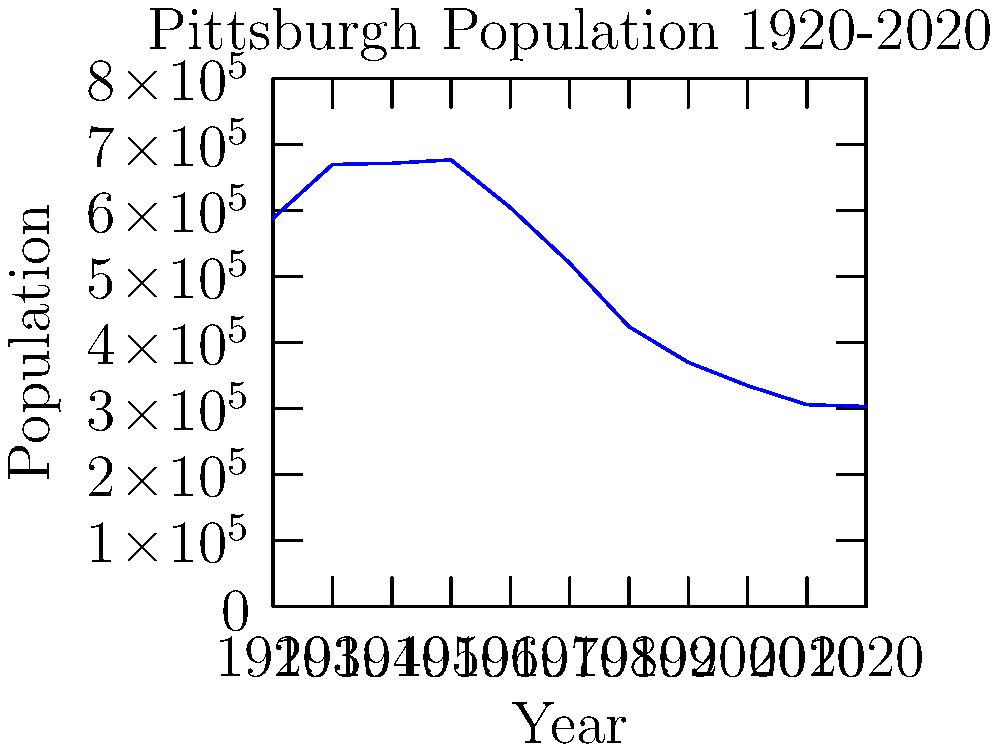The graph shows Pittsburgh's population from 1920 to 2020. During which decade did Pittsburgh experience the most significant population decline in terms of absolute numbers? What was the percentage decrease during this decade? To solve this problem, we need to follow these steps:

1. Calculate the population change for each decade.
2. Identify the decade with the largest absolute decrease.
3. Calculate the percentage decrease for that decade.

Population changes by decade:
1920-1930: 669817 - 588343 = +81474
1930-1940: 671659 - 669817 = +1842
1940-1950: 676806 - 671659 = +5147
1950-1960: 604332 - 676806 = -72474
1960-1970: 520117 - 604332 = -84215
1970-1980: 423938 - 520117 = -96179
1980-1990: 369879 - 423938 = -54059
1990-2000: 334563 - 369879 = -35316
2000-2010: 305704 - 334563 = -28859
2010-2020: 302971 - 305704 = -2733

The largest absolute decrease occurred between 1970 and 1980, with a loss of 96,179 people.

To calculate the percentage decrease:

Percentage decrease = (Decrease / Original Value) × 100
= (96179 / 520117) × 100
≈ 18.49%
Answer: 1970-1980; 18.49% 